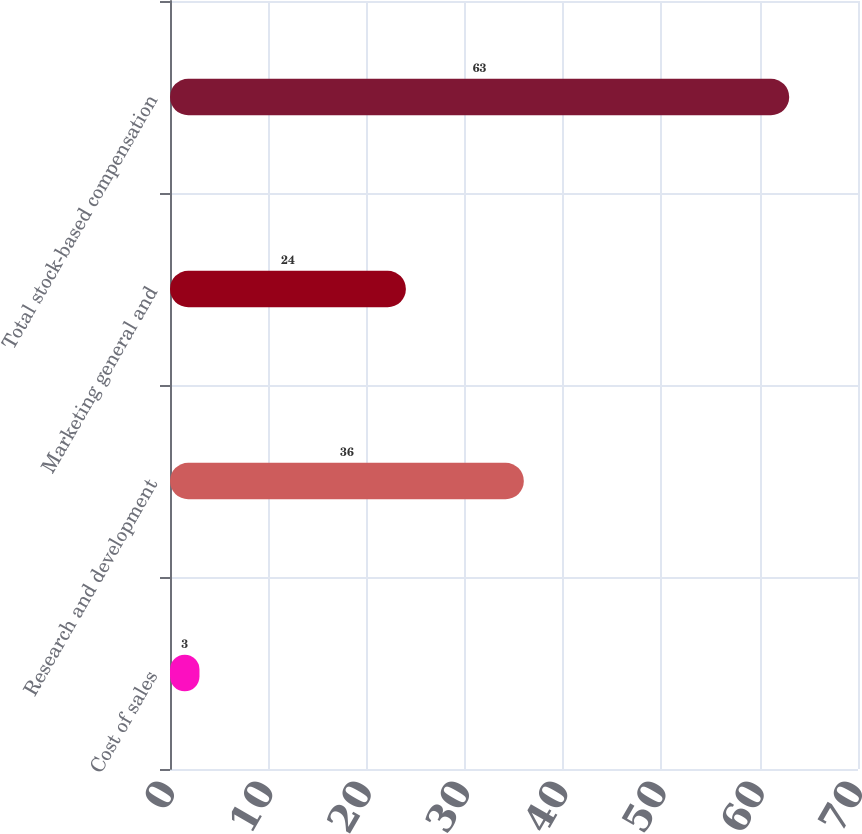Convert chart. <chart><loc_0><loc_0><loc_500><loc_500><bar_chart><fcel>Cost of sales<fcel>Research and development<fcel>Marketing general and<fcel>Total stock-based compensation<nl><fcel>3<fcel>36<fcel>24<fcel>63<nl></chart> 